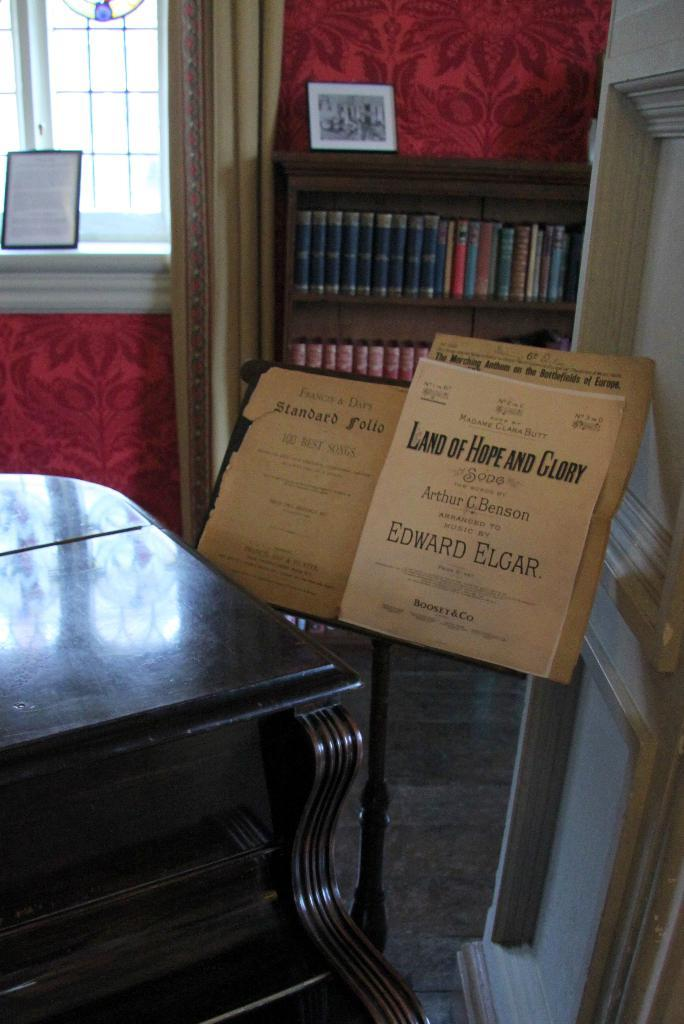<image>
Write a terse but informative summary of the picture. Land of Hope and Glory by Edward Elgar is sitting on a music stand. 